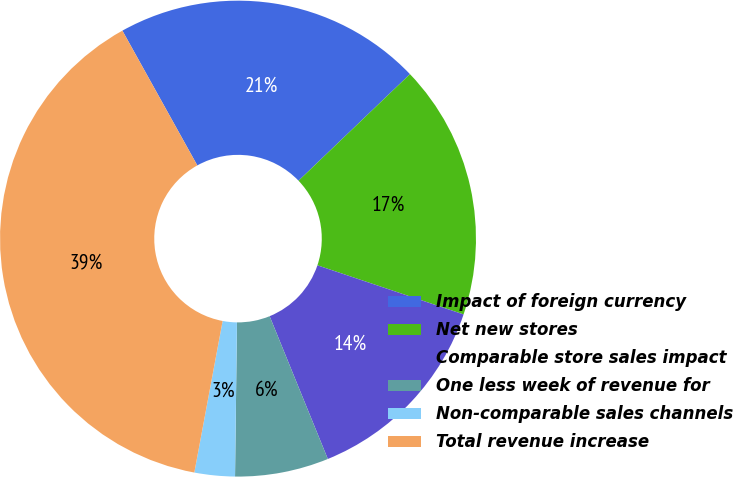Convert chart. <chart><loc_0><loc_0><loc_500><loc_500><pie_chart><fcel>Impact of foreign currency<fcel>Net new stores<fcel>Comparable store sales impact<fcel>One less week of revenue for<fcel>Non-comparable sales channels<fcel>Total revenue increase<nl><fcel>20.93%<fcel>17.31%<fcel>13.68%<fcel>6.36%<fcel>2.74%<fcel>38.99%<nl></chart> 